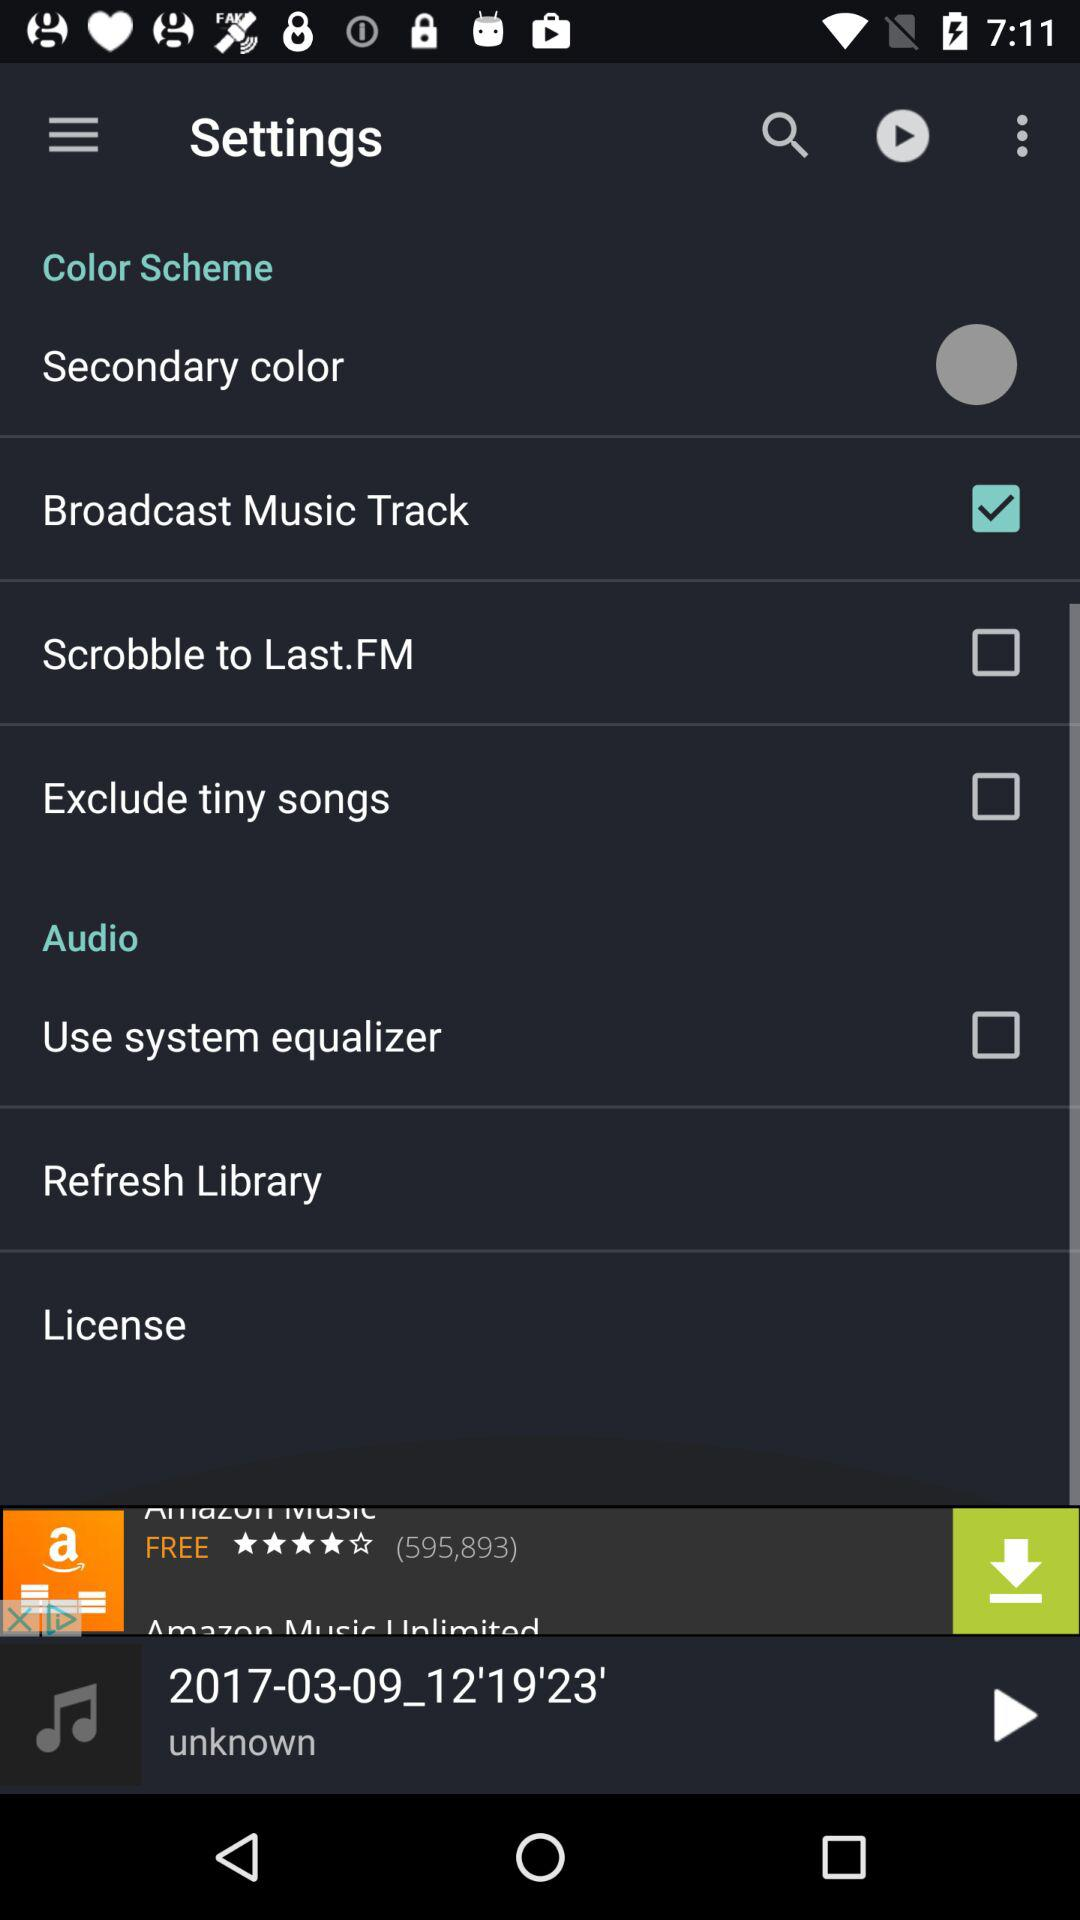What is the status of the "Use system equalizer"? The status is "off". 